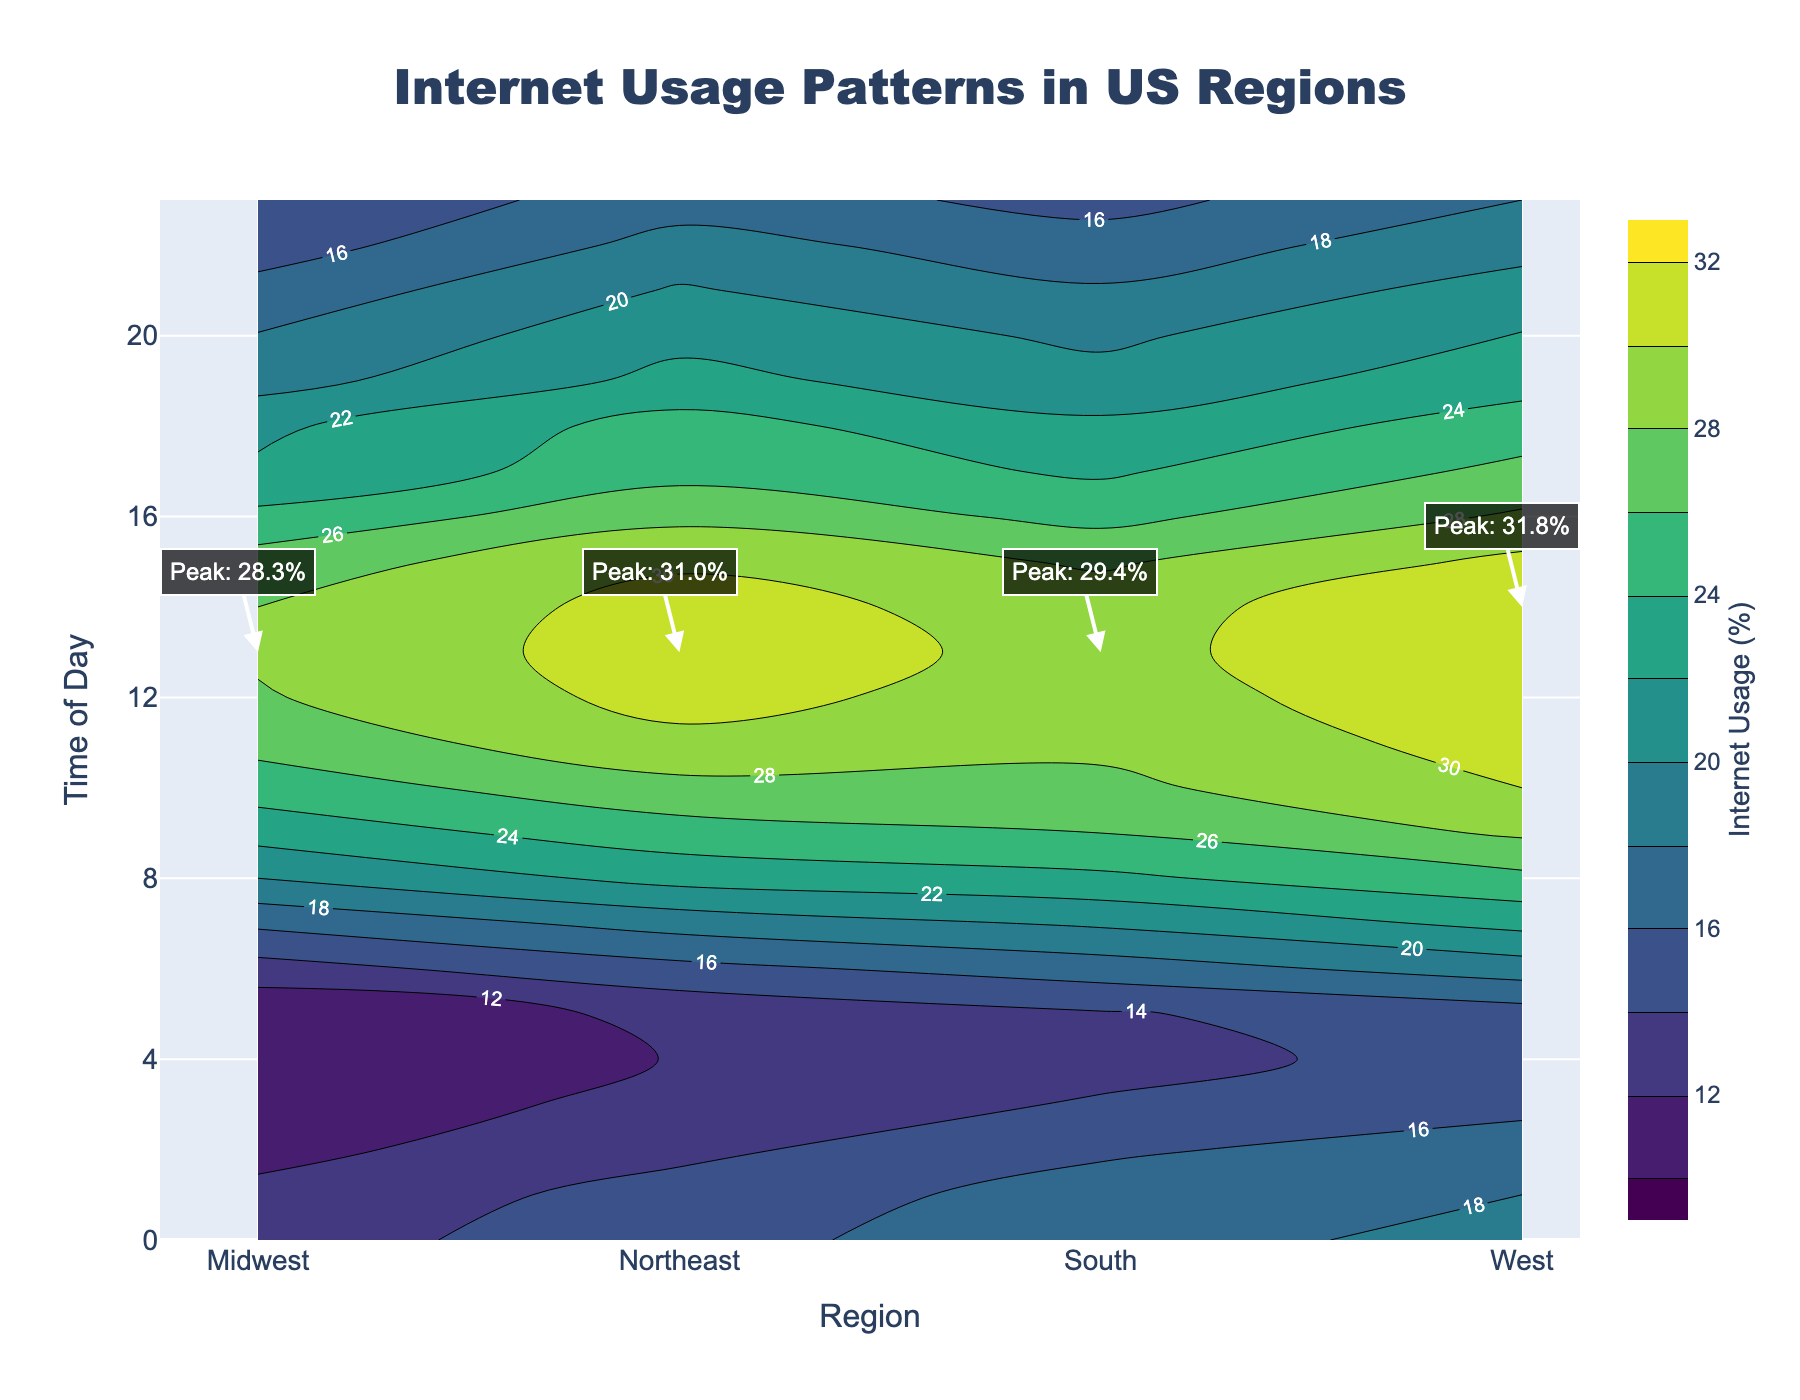What's the title of the figure? The title is located at the top of the figure. Referencing the title text, the title is "Internet Usage Patterns in US Regions".
Answer: Internet Usage Patterns in US Regions What does the color bar represent? The color bar is accompanied by a title, which explains the representation of colors. According to its label, it represents "Internet Usage (%)".
Answer: Internet Usage (%) At what time does the Northeast region experience its peak internet usage? Look for the annotation on the plot corresponding to the Northeast region. The annotation indicates the time and value of peak usage. According to the figure, the peak usage for the Northeast is at 13:00.
Answer: 13:00 Which region shows the lowest internet usage at 3 AM? To determine the lowest usage, compare the contours or labels at 3 AM across all regions. The Midwest region shows the lowest usage at 3 AM with approximately 10.6%.
Answer: Midwest What is the difference in peak internet usage between the West and South regions? Check the annotations in the figure for the peak values in the West and South regions. The peak in the West is 31.8% and in the South is 29.4%. Subtract 29.4% from 31.8% to find the difference.
Answer: 2.4% During what hours does the Northeast region's internet usage exceed 25%? Examine the contour lines and labels to see where the internet usage exceeds 25% for the Northeast region. It consistently exceeds 25% between 9:00 and 18:00.
Answer: 9:00 to 18:00 Which region has the steepest increase in internet usage from early morning to noon? Compare the gradients of internet usage rise between 6:00 AM and 12:00 PM across all regions. The West region shows the most pronounced increase.
Answer: West How does the South's internet usage at 10 AM compare to its usage at 3 AM? Evaluate the contour labels or lines for the South region at 10 AM and 3 AM. At 10 AM, the usage is around 27.5%, and at 3 AM it's about 14.2%. The usage at 10 AM is significantly higher.
Answer: Higher at 10 AM If you average the peak internet usages across all regions, what do you get? Sum up the peak values for all regions: Northeast (31.0%), Midwest (28.3%), South (29.4%), West (31.8%). Divide by the number of regions: (31.0% + 28.3% + 29.4% + 31.8%) / 4 = 30.125%.
Answer: 30.125% 